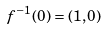<formula> <loc_0><loc_0><loc_500><loc_500>f ^ { - 1 } ( 0 ) = ( 1 , 0 )</formula> 